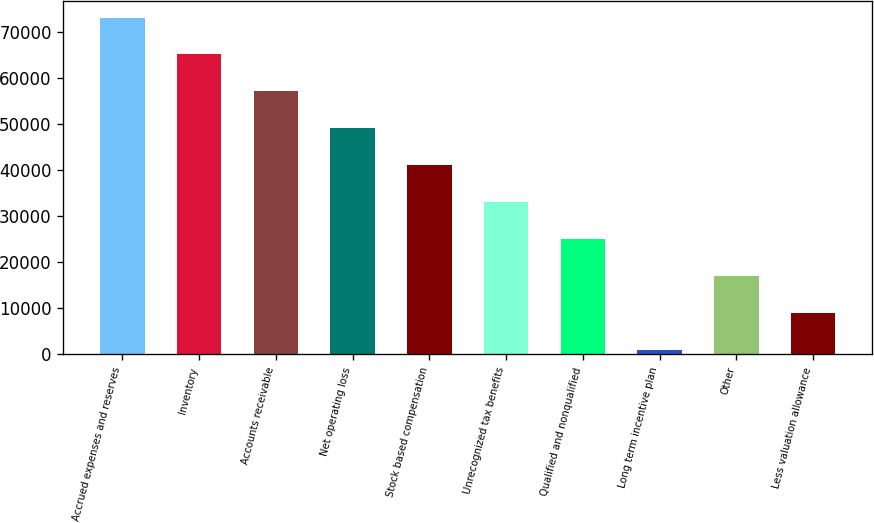Convert chart. <chart><loc_0><loc_0><loc_500><loc_500><bar_chart><fcel>Accrued expenses and reserves<fcel>Inventory<fcel>Accounts receivable<fcel>Net operating loss<fcel>Stock based compensation<fcel>Unrecognized tax benefits<fcel>Qualified and nonqualified<fcel>Long term incentive plan<fcel>Other<fcel>Less valuation allowance<nl><fcel>73151.1<fcel>65134.2<fcel>57117.3<fcel>49100.4<fcel>41083.5<fcel>33066.6<fcel>25049.7<fcel>999<fcel>17032.8<fcel>9015.9<nl></chart> 